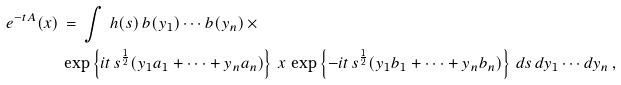<formula> <loc_0><loc_0><loc_500><loc_500>e ^ { - t A } ( x ) \, & = \, \int \, h ( s ) \, b ( y _ { 1 } ) \cdots b ( y _ { n } ) \, \times \\ & \exp \left \{ i t \, s ^ { \frac { 1 } { 2 } } ( y _ { 1 } a _ { 1 } + \cdots + y _ { n } a _ { n } ) \right \} \, x \, \exp \left \{ - i t \, s ^ { \frac { 1 } { 2 } } ( y _ { 1 } b _ { 1 } + \cdots + y _ { n } b _ { n } ) \right \} \, d s \, d y _ { 1 } \cdots d y _ { n } \, ,</formula> 